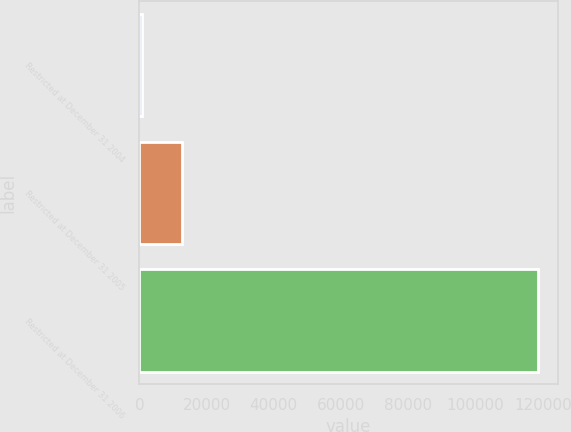Convert chart. <chart><loc_0><loc_0><loc_500><loc_500><bar_chart><fcel>Restricted at December 31 2004<fcel>Restricted at December 31 2005<fcel>Restricted at December 31 2006<nl><fcel>844<fcel>12619.8<fcel>118602<nl></chart> 